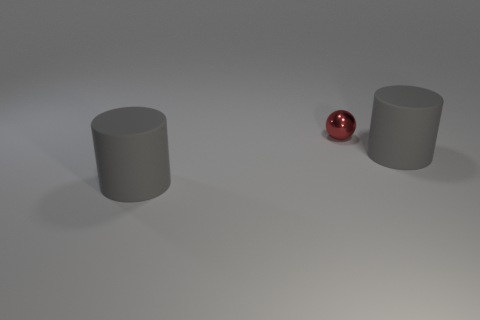What could be the purpose of this arrangement? This scene could be a setup to showcase object reflections, lighting effects, or simply as an artistic composition. The minimalist aesthetic evokes a sense of calm and balance, with the red ball drawing the viewer's focus amidst the neutral grey tones. 